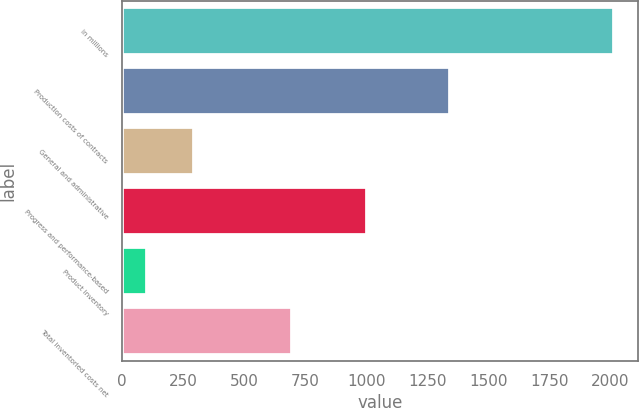Convert chart. <chart><loc_0><loc_0><loc_500><loc_500><bar_chart><fcel>in millions<fcel>Production costs of contracts<fcel>General and administrative<fcel>Progress and performance-based<fcel>Product inventory<fcel>Total inventoried costs net<nl><fcel>2013<fcel>1342<fcel>293.1<fcel>1005<fcel>102<fcel>698<nl></chart> 